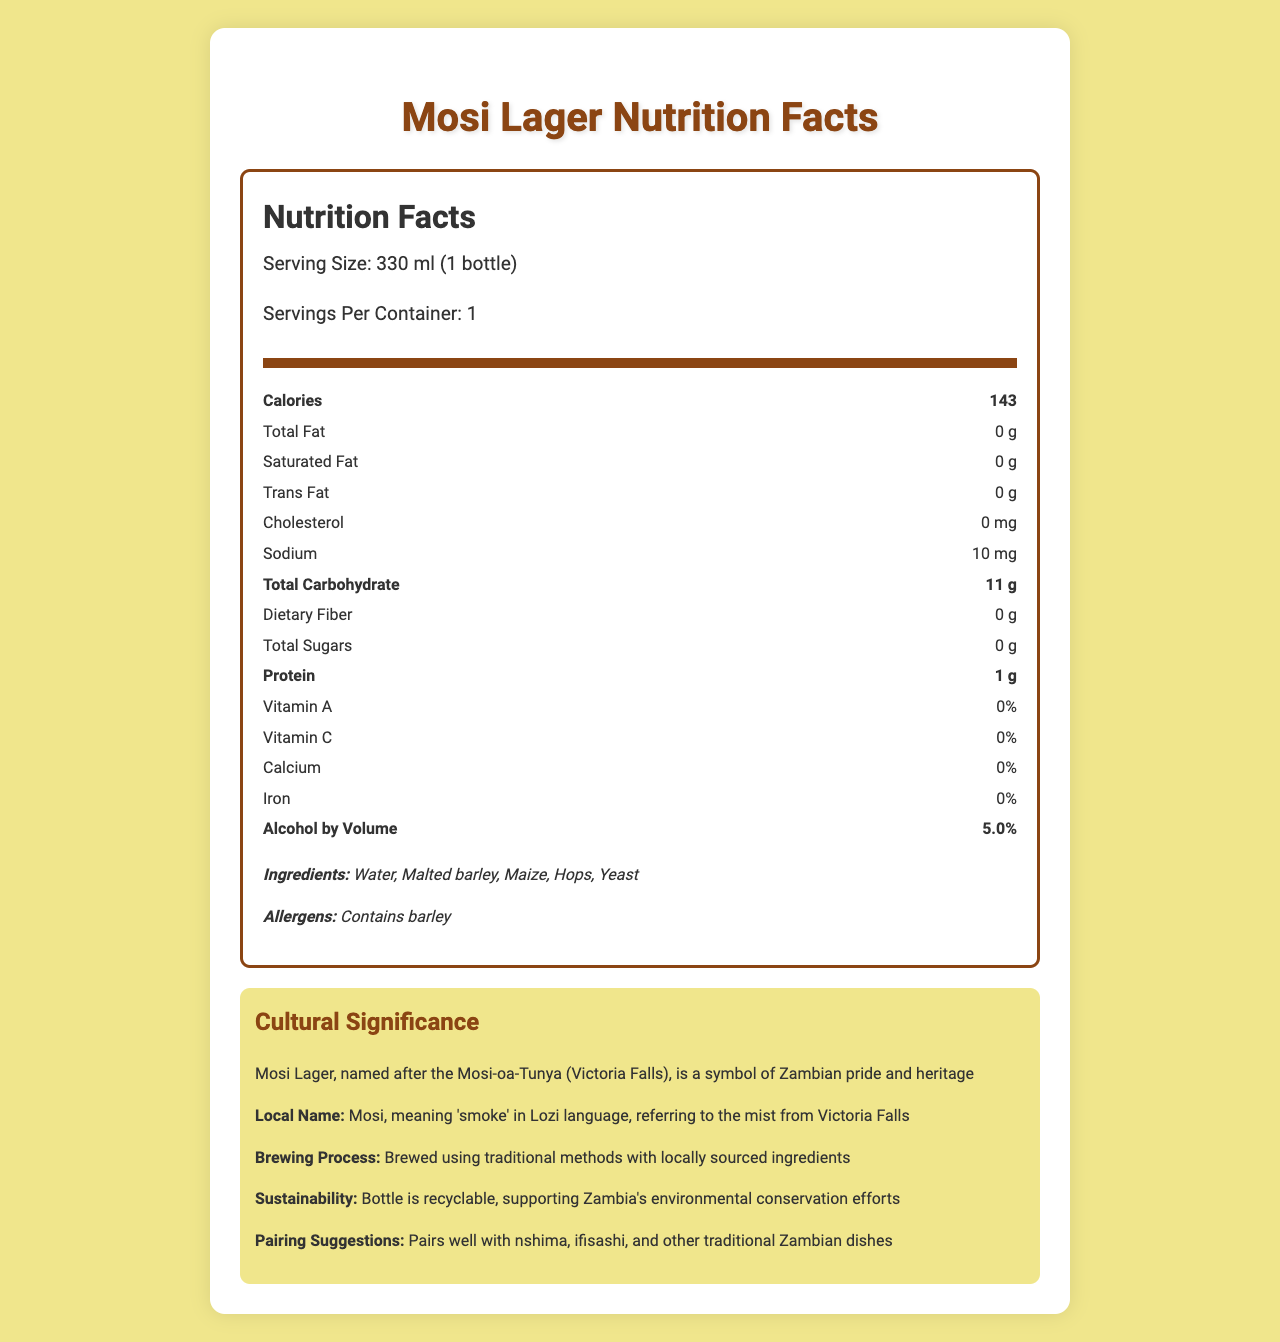what is the serving size for Mosi Lager? The document states that the serving size is 330 ml, which is equivalent to one bottle.
Answer: 330 ml (1 bottle) how many calories are in one serving of Mosi Lager? The document states that one serving of Mosi Lager contains 143 calories.
Answer: 143 what ingredients are used in Mosi Lager? The ingredient list in the document specifies these components.
Answer: Water, Malted barley, Maize, Hops, Yeast what is the sodium content in Mosi Lager? The document mentions that the sodium content per serving is 10 mg.
Answer: 10 mg does Mosi Lager contain any dietary fiber? The document states that the dietary fiber content is 0 g.
Answer: No how should Mosi Lager be stored? The storage instructions in the document specify these conditions.
Answer: Store in a cool, dry place away from direct sunlight what local names and cultural significances are associated with Mosi Lager? The document provides both the cultural significance and the local name.
Answer: Local Name: Mosi, meaning 'smoke' in Lozi language, referring to the mist from Victoria Falls; Cultural Significance: Symbol of Zambian pride and heritage which nutrient has the highest percentage of Daily Value in Mosi Lager? A. Vitamin A B. Sodium C. Protein D. Alcohol The alcohol by volume is 5.0%, which indicates a significant content compared to other nutrients listed.
Answer: D. Alcohol which vitamin content is indicated in Mosi Lager? A. Vitamin A B. Vitamin C C. Both A & B D. Neither The document states that both Vitamin A and Vitamin C are at 0%.
Answer: D. Neither is the bottle of Mosi Lager recyclable? The document mentions that the bottle is recyclable.
Answer: Yes what are the pairing suggestions for Mosi Lager? The document provides specific pairing suggestions with traditional Zambian dishes.
Answer: Pairs well with nshima, ifisashi, and other traditional Zambian dishes summarize the main idea of the document. The document is comprehensive and includes nutritional information, cultural background, and additional details.
Answer: The document provides detailed nutrition facts for Mosi Lager, including calorie content, ingredients, and serving size. It also highlights the cultural significance, local name, storage instructions, sustainability efforts, and pairing suggestions with traditional Zambian dishes. where can one find the best price for Mosi Lager? The document does not provide information about the price or where to find the best price for Mosi Lager.
Answer: I don't know 